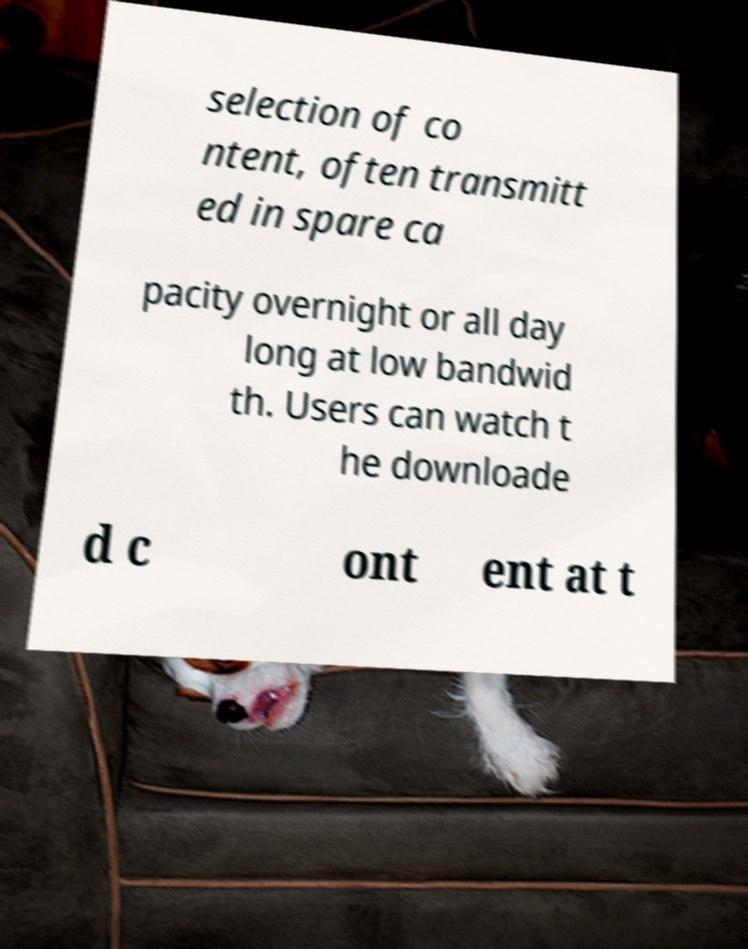Please identify and transcribe the text found in this image. selection of co ntent, often transmitt ed in spare ca pacity overnight or all day long at low bandwid th. Users can watch t he downloade d c ont ent at t 